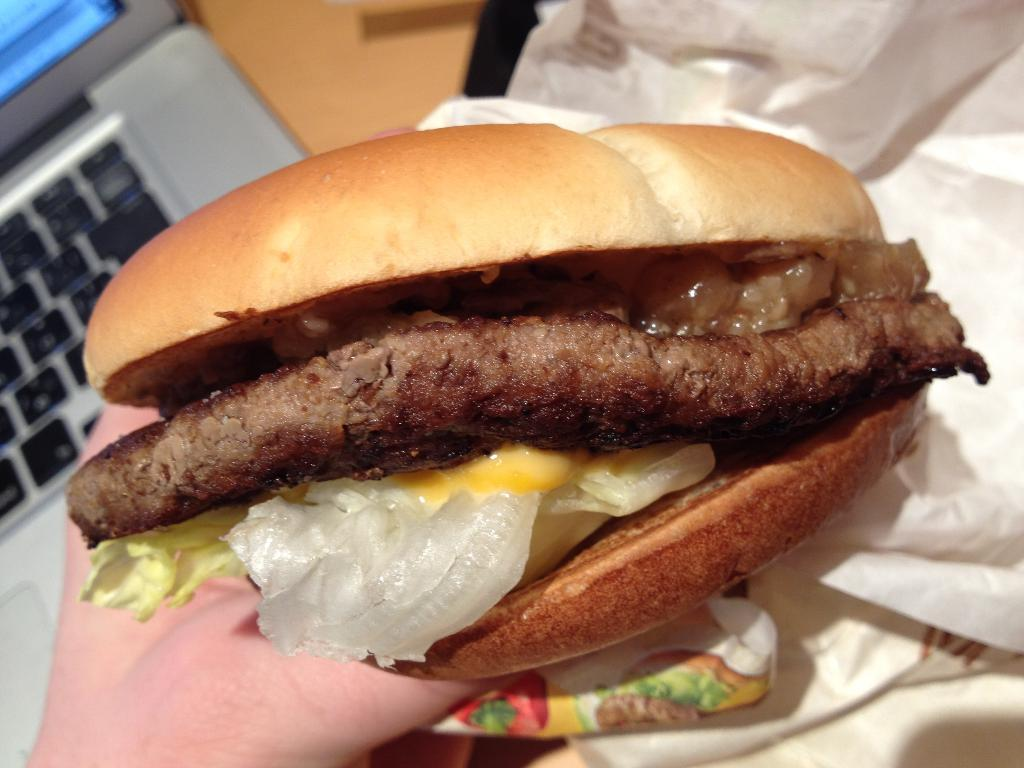What type of food is visible in the image? There is a burger in the image. Who is holding the burger in the image? A person is holding the burger in the image. What electronic device can be seen in the image? There is a laptop in the image. What else is present in the image besides the burger and laptop? There is a wrapper in the image. What type of border is visible in the image? There is no border visible in the image. Can you tell me what the person and the laptop are arguing about in the image? There is no argument present in the image; the person is simply holding a burger and there is a laptop nearby. 